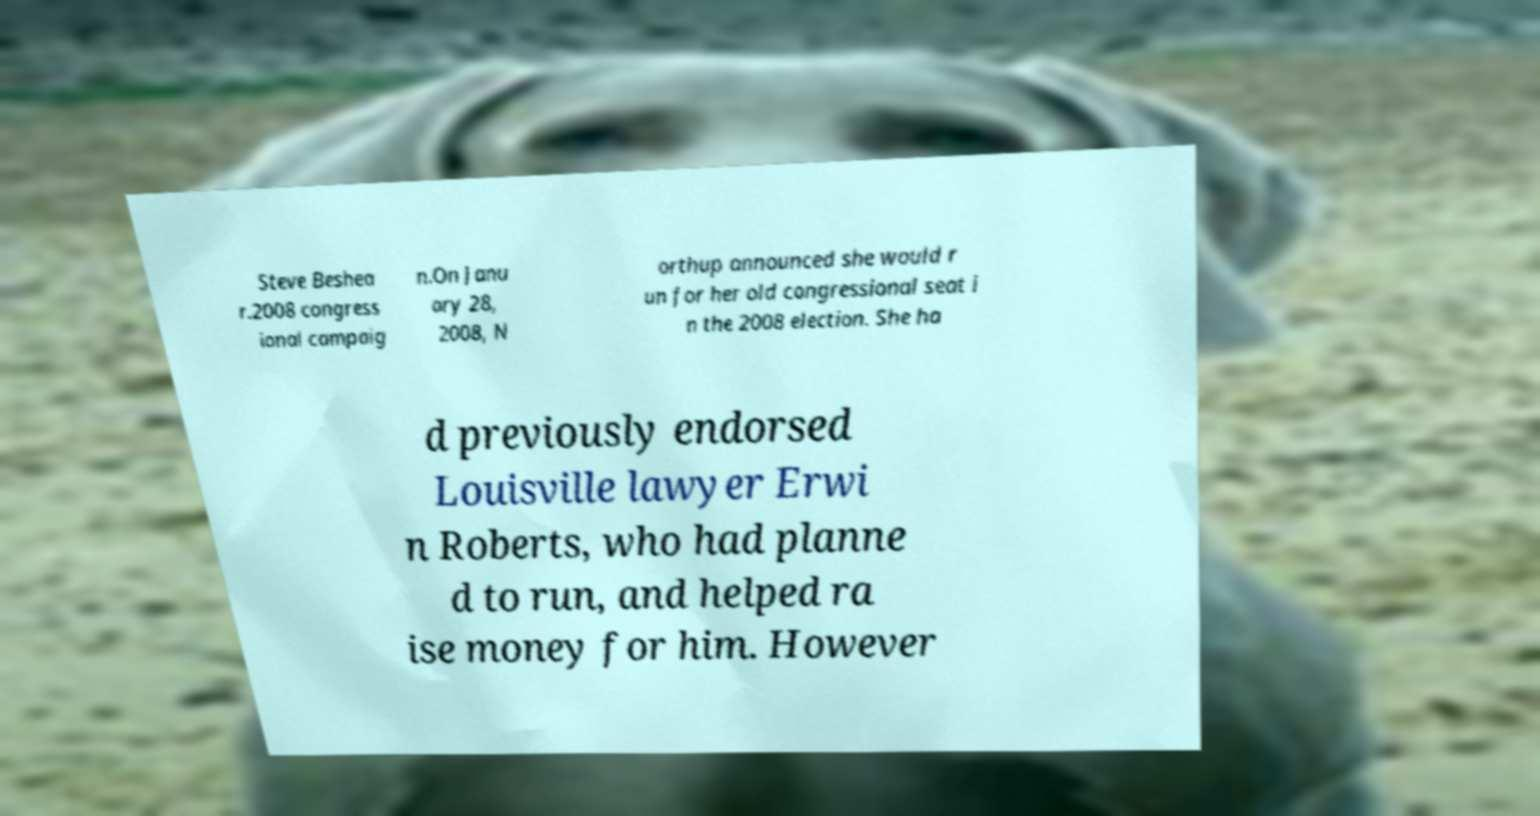For documentation purposes, I need the text within this image transcribed. Could you provide that? Steve Beshea r.2008 congress ional campaig n.On Janu ary 28, 2008, N orthup announced she would r un for her old congressional seat i n the 2008 election. She ha d previously endorsed Louisville lawyer Erwi n Roberts, who had planne d to run, and helped ra ise money for him. However 